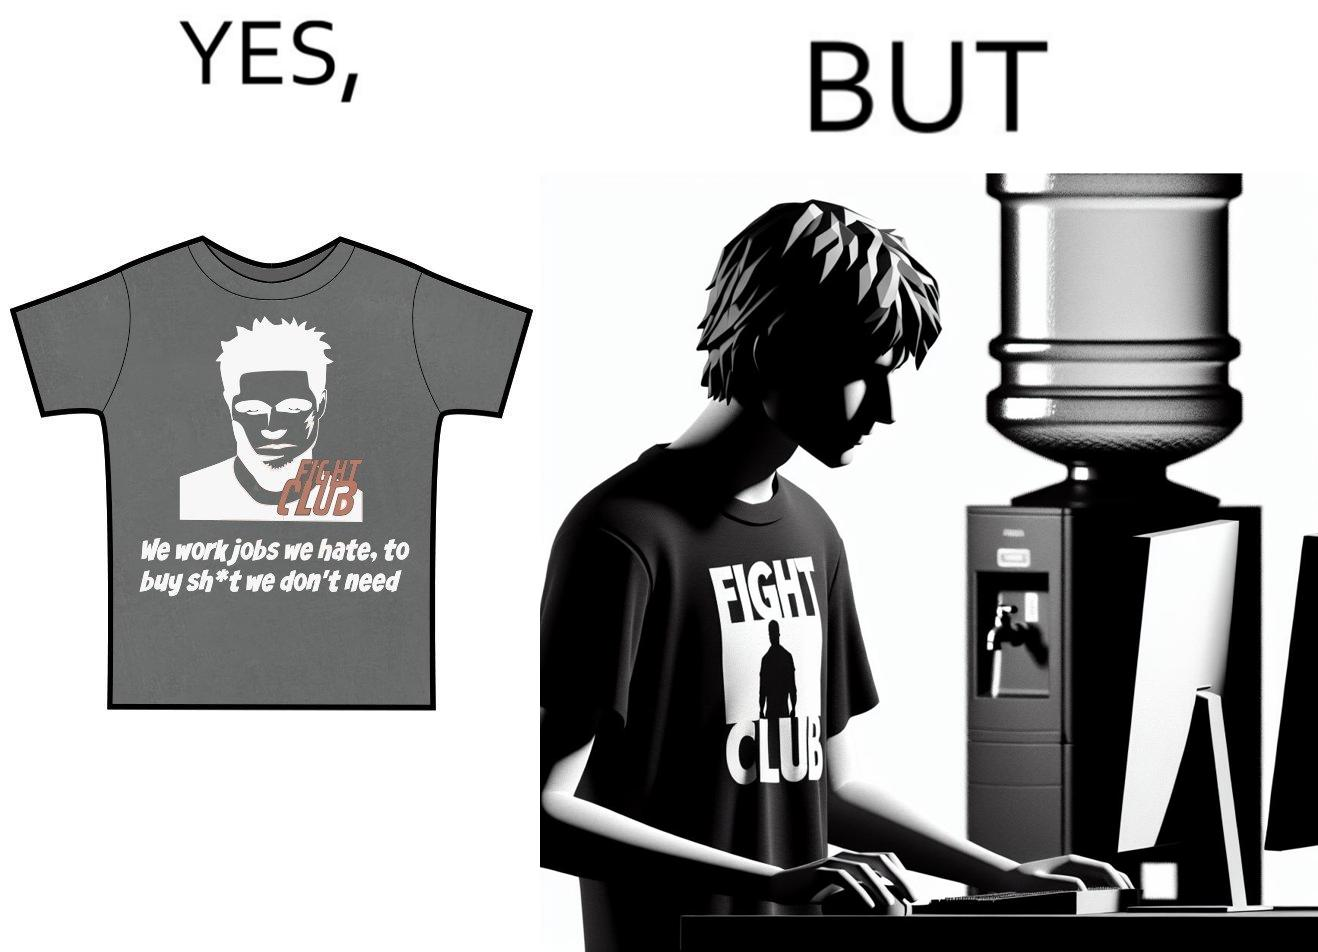Describe what you see in the left and right parts of this image. In the left part of the image: a t-shirt with "Fight Club" written on it (referring to the movie), along with a dialogue from the movie that says "We work jobs we hate, to buy sh*t we don't need". In the right part of the image: a person wearing a t-shirt that says "Fight Club", working on a computer system, with a water dispenser by the side. 